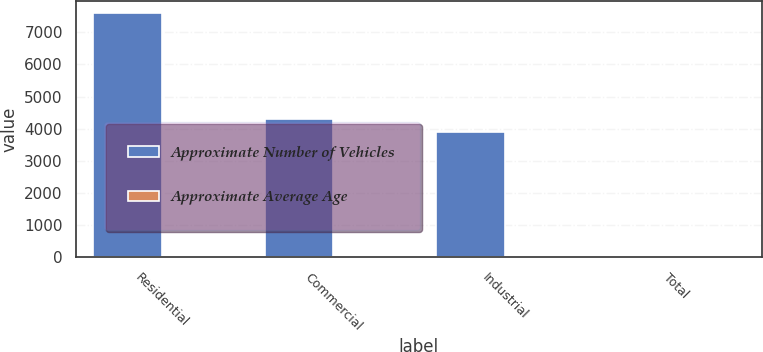Convert chart to OTSL. <chart><loc_0><loc_0><loc_500><loc_500><stacked_bar_chart><ecel><fcel>Residential<fcel>Commercial<fcel>Industrial<fcel>Total<nl><fcel>Approximate Number of Vehicles<fcel>7600<fcel>4300<fcel>3900<fcel>9<nl><fcel>Approximate Average Age<fcel>7<fcel>7<fcel>9<fcel>7.5<nl></chart> 